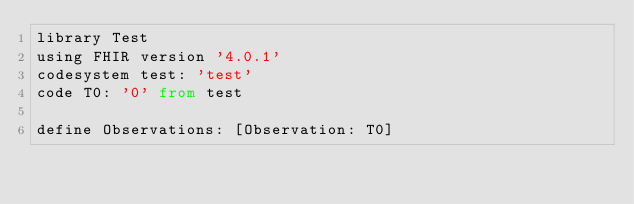Convert code to text. <code><loc_0><loc_0><loc_500><loc_500><_SQL_>library Test
using FHIR version '4.0.1'
codesystem test: 'test'
code T0: '0' from test

define Observations: [Observation: T0]</code> 